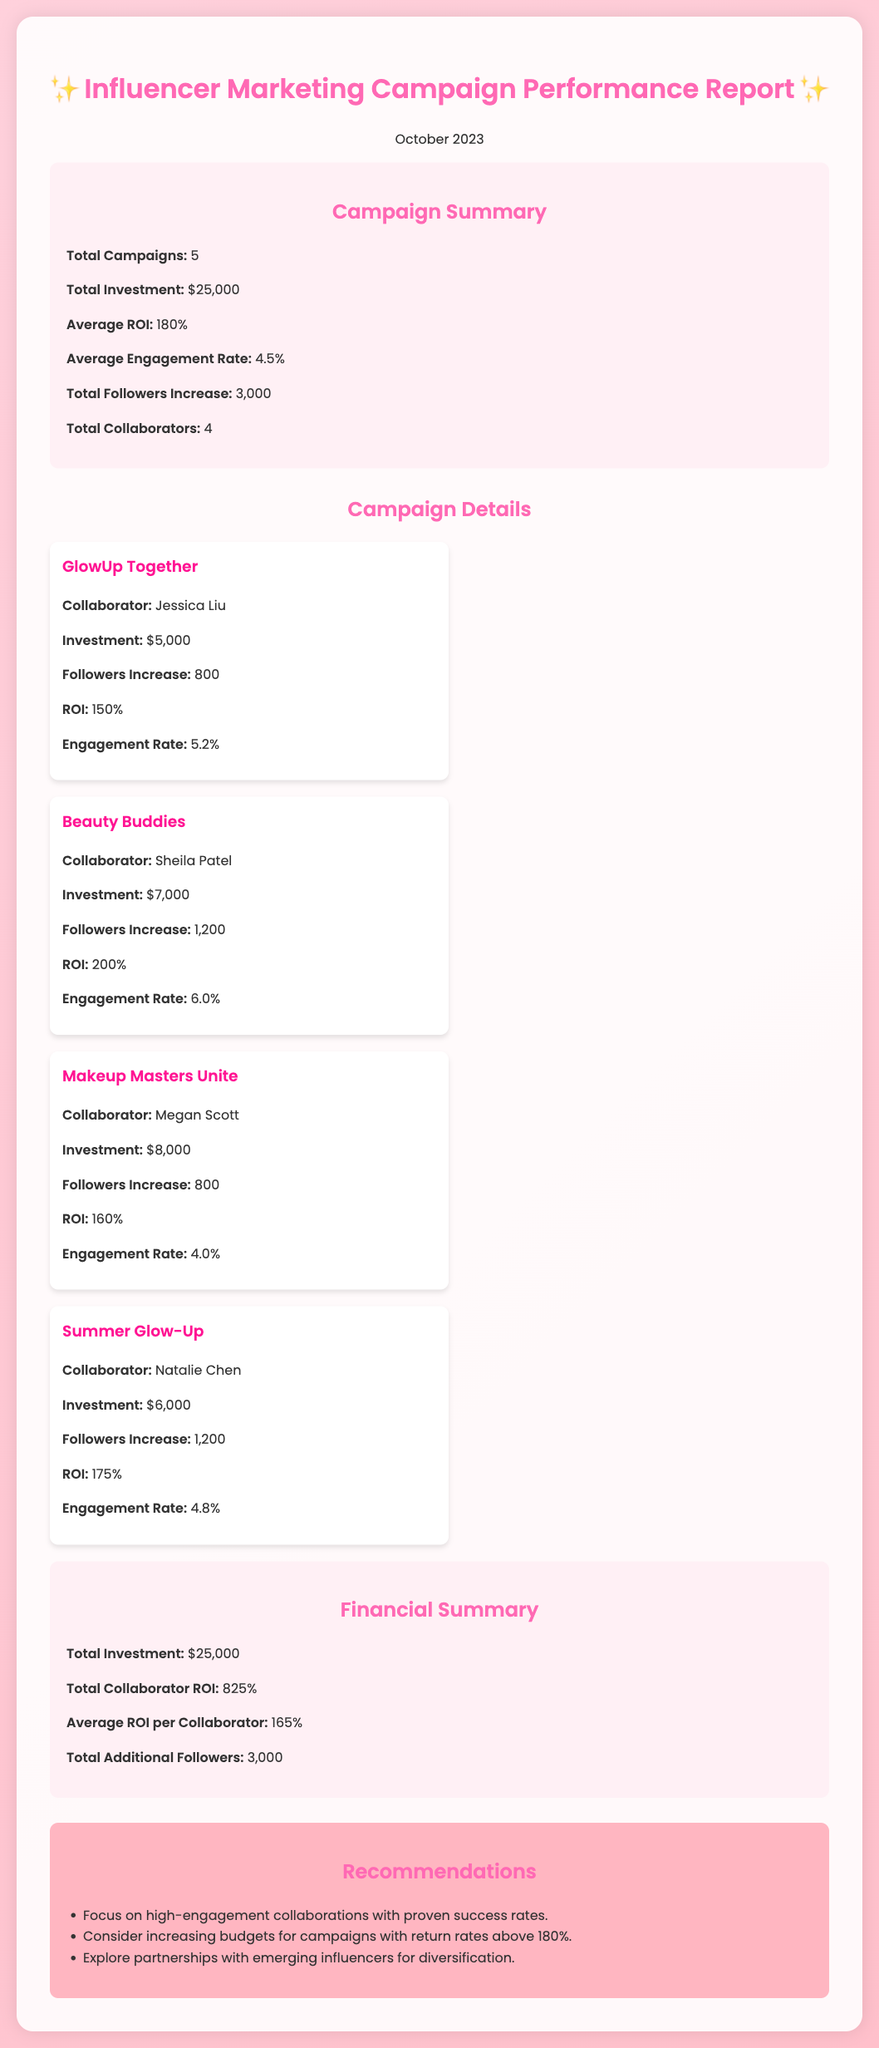What is the total number of campaigns? The document states that there are a total of 5 campaigns conducted.
Answer: 5 What was the total investment made in the campaigns? The report indicates that the total investment for all campaigns is $25,000.
Answer: $25,000 What was the average ROI reported? The average return on investment (ROI) across the campaigns is mentioned as 180%.
Answer: 180% Which collaborator had the highest engagement rate? The engagement rates of different collaborators show that Sheila Patel had the highest engagement rate of 6.0%.
Answer: Sheila Patel What is the total followers increase from all campaigns? The summary specifies that the total followers increase over all campaigns is 3,000.
Answer: 3,000 Which campaign had the greatest increase in followers? The report lists that the "Beauty Buddies" campaign resulted in an increase of 1,200 followers, which is the highest.
Answer: Beauty Buddies What is the total collaborator ROI? The document states that the total ROI from all collaborators is 825%.
Answer: 825% What is the average engagement rate across all campaigns? The report summarizes that the average engagement rate across all campaigns is 4.5%.
Answer: 4.5% What recommendation is given regarding campaign budgets? The recommendations suggest considering increasing budgets for campaigns with return rates above 180%.
Answer: Increase budgets for campaigns above 180% ROI 